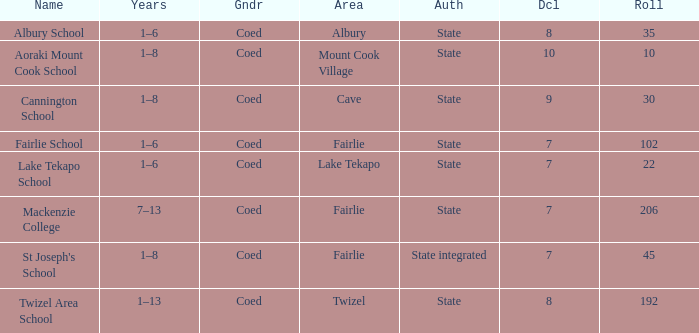What is the total Decile that has a state authority, fairlie area and roll smarter than 206? 1.0. 